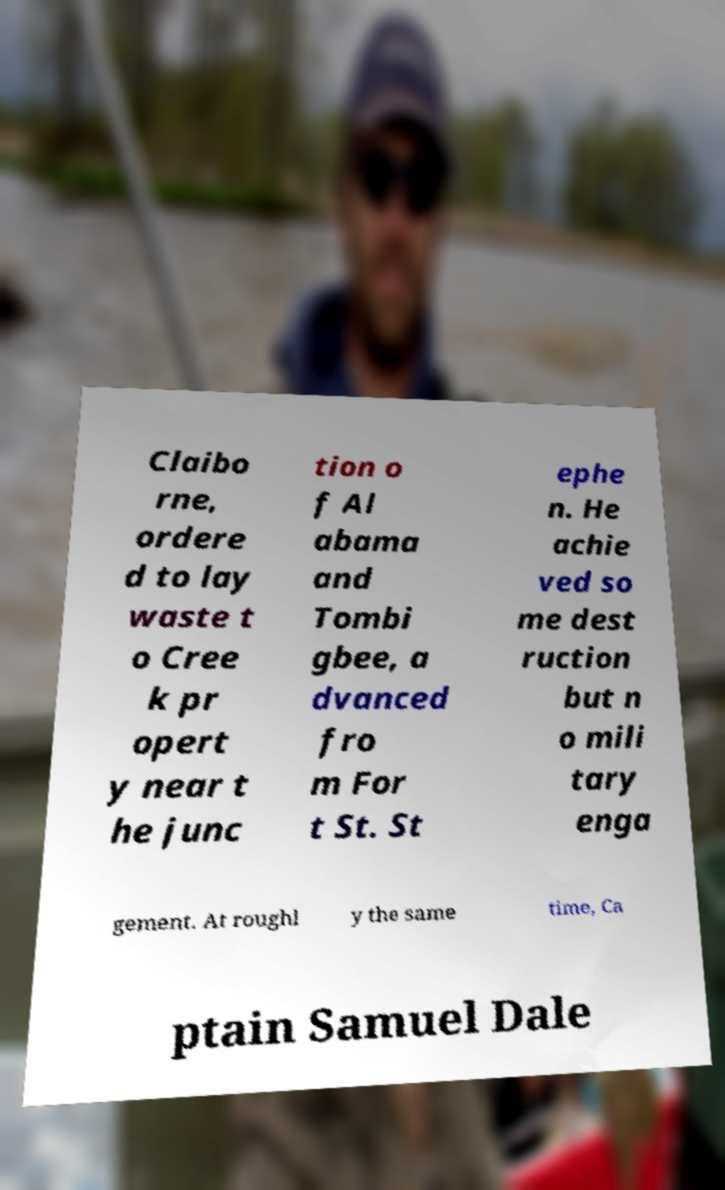Could you assist in decoding the text presented in this image and type it out clearly? Claibo rne, ordere d to lay waste t o Cree k pr opert y near t he junc tion o f Al abama and Tombi gbee, a dvanced fro m For t St. St ephe n. He achie ved so me dest ruction but n o mili tary enga gement. At roughl y the same time, Ca ptain Samuel Dale 